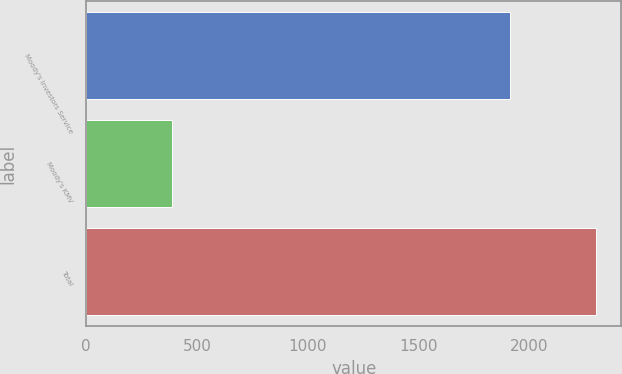<chart> <loc_0><loc_0><loc_500><loc_500><bar_chart><fcel>Moody's Investors Service<fcel>Moody's KMV<fcel>Total<nl><fcel>1913<fcel>387<fcel>2300<nl></chart> 